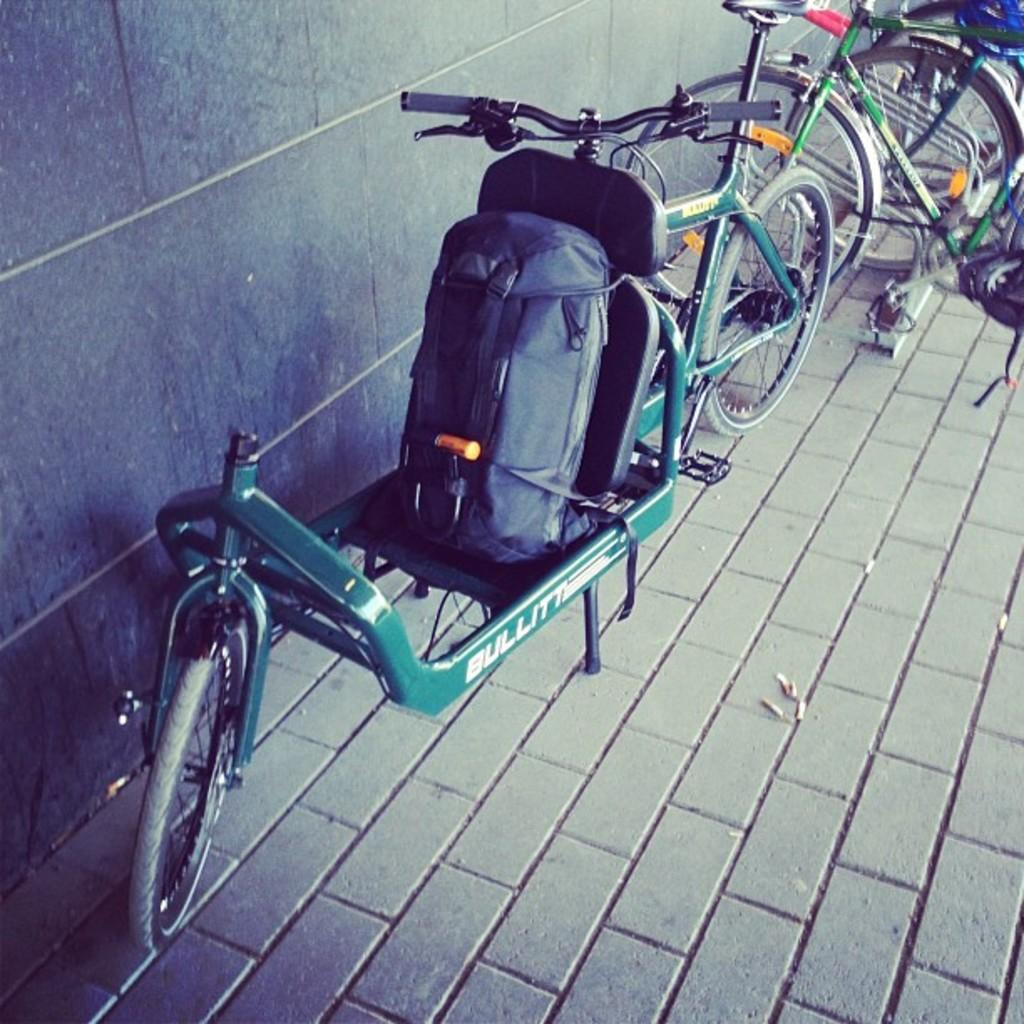What is the main subject in the middle of the image? There are many cycles in the middle of the image. What can be seen on the left side of the image? There is a vehicle on the left side of the image. What is attached to the vehicle? The vehicle has a backpack on it. What is visible in the background of the image? There is a wall in the background of the image. How many mice are sitting on the cycles in the image? There are no mice present in the image; it features cycles and a vehicle. Are there any women riding the cycles in the image? There is no information about women riding the cycles in the image. Can you see any boats in the image? There is no mention of boats in the image; it features cycles, a vehicle, and a wall in the background. 